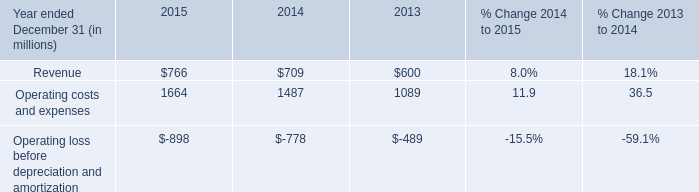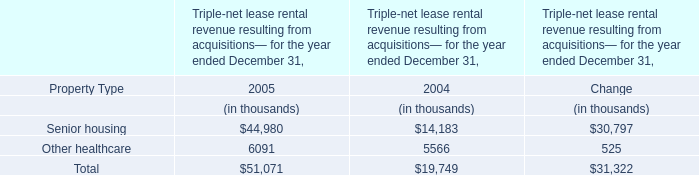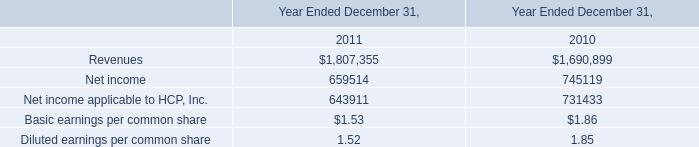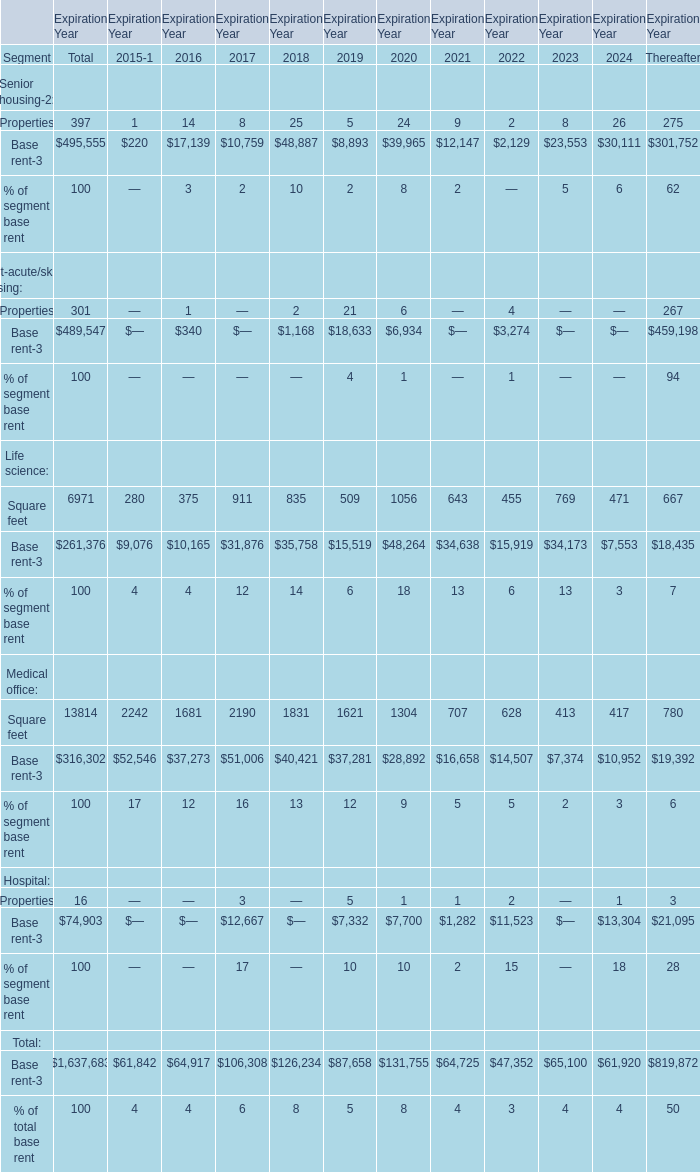What is the sum of Senior housing in 2005 and Revenues in 2011? (in thousand) 
Computations: (44980 + 1807355)
Answer: 1852335.0. 